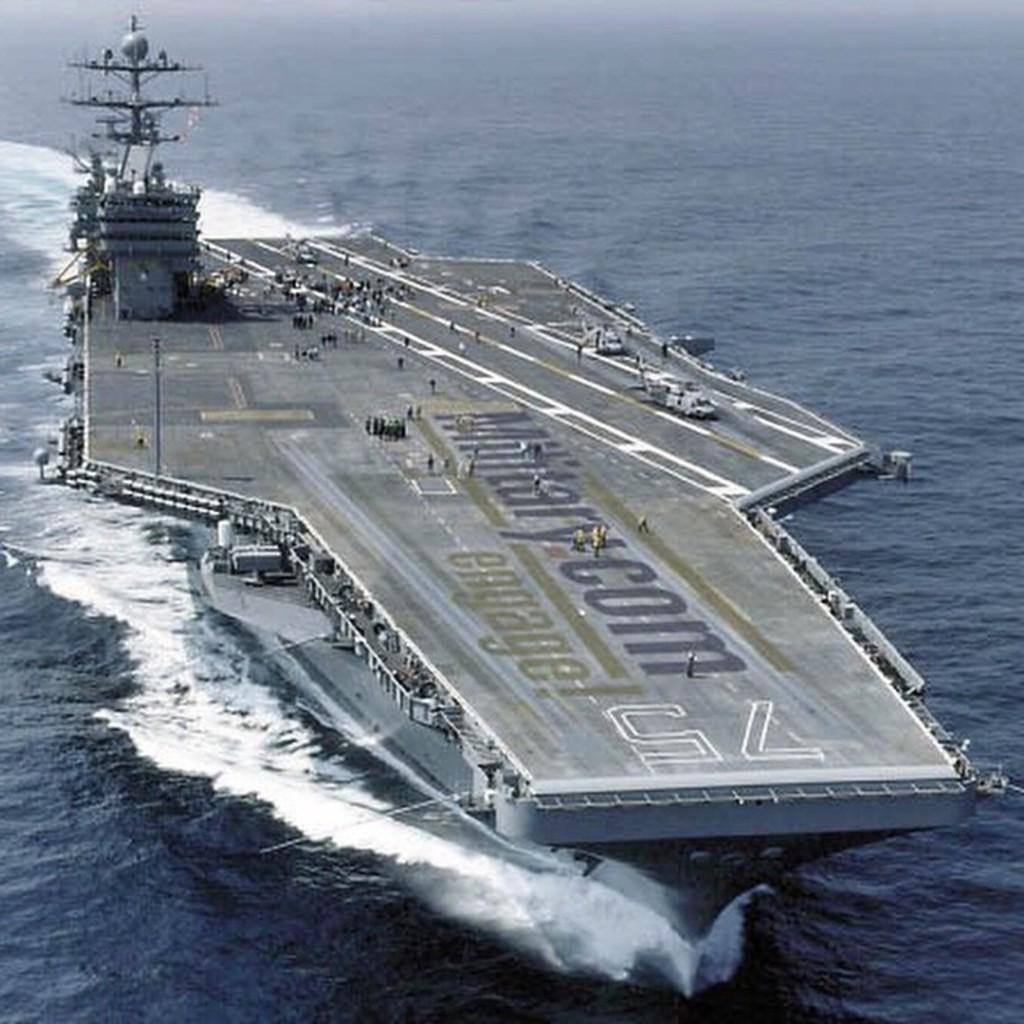In one or two sentences, can you explain what this image depicts? The picture consists of a war ship, on the ship we can see people, aircraft and other objects. In this picture there is a water body. 